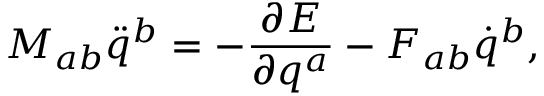<formula> <loc_0><loc_0><loc_500><loc_500>M _ { a b } \ddot { q } ^ { b } = - \frac { \partial E } { \partial q ^ { a } } - F _ { a b } \dot { q } ^ { b } ,</formula> 